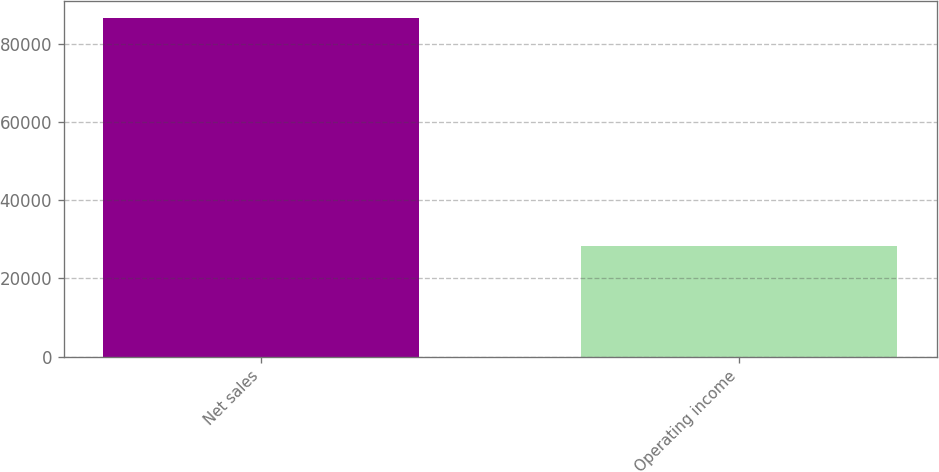Convert chart. <chart><loc_0><loc_0><loc_500><loc_500><bar_chart><fcel>Net sales<fcel>Operating income<nl><fcel>86613<fcel>28172<nl></chart> 